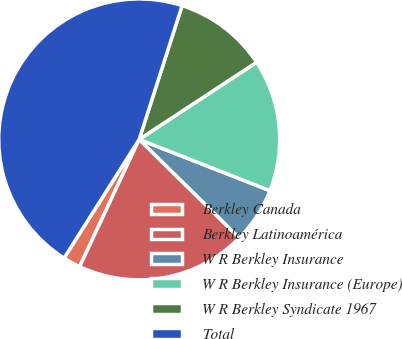Convert chart to OTSL. <chart><loc_0><loc_0><loc_500><loc_500><pie_chart><fcel>Berkley Canada<fcel>Berkley Latinoamérica<fcel>W R Berkley Insurance<fcel>W R Berkley Insurance (Europe)<fcel>W R Berkley Syndicate 1967<fcel>Total<nl><fcel>2.02%<fcel>19.6%<fcel>6.42%<fcel>15.2%<fcel>10.81%<fcel>45.96%<nl></chart> 